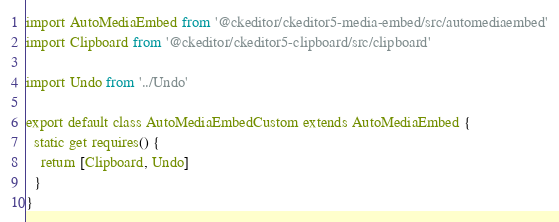<code> <loc_0><loc_0><loc_500><loc_500><_JavaScript_>import AutoMediaEmbed from '@ckeditor/ckeditor5-media-embed/src/automediaembed'
import Clipboard from '@ckeditor/ckeditor5-clipboard/src/clipboard'

import Undo from '../Undo'

export default class AutoMediaEmbedCustom extends AutoMediaEmbed {
  static get requires() {
    return [Clipboard, Undo]
  }
}
</code> 